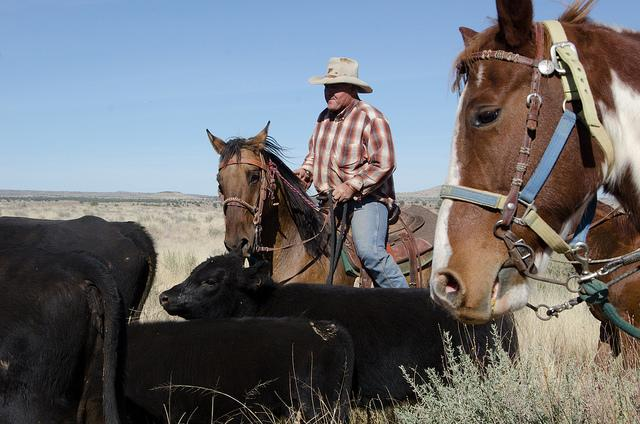How did this man get to this location?

Choices:
A) walk
B) uber
C) via horseback
D) cow back via horseback 